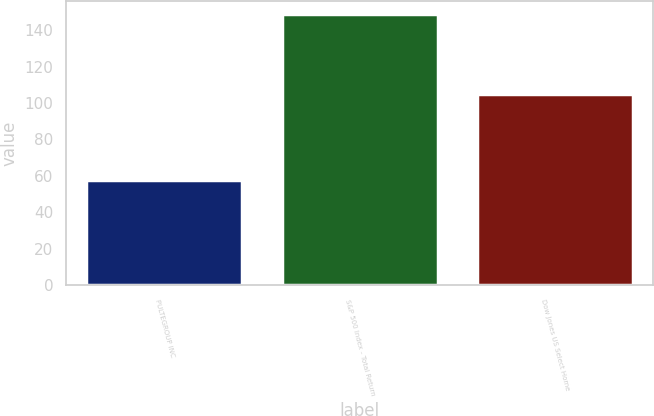<chart> <loc_0><loc_0><loc_500><loc_500><bar_chart><fcel>PULTEGROUP INC<fcel>S&P 500 Index - Total Return<fcel>Dow Jones US Select Home<nl><fcel>57.73<fcel>148.59<fcel>104.9<nl></chart> 